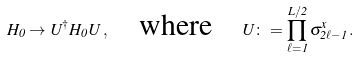Convert formula to latex. <formula><loc_0><loc_0><loc_500><loc_500>H _ { 0 } \to U ^ { \dag } H _ { 0 } U \, , \quad \text {where} \quad U \colon = \prod _ { \ell = 1 } ^ { L / 2 } \sigma ^ { x } _ { 2 \ell - 1 } \, .</formula> 